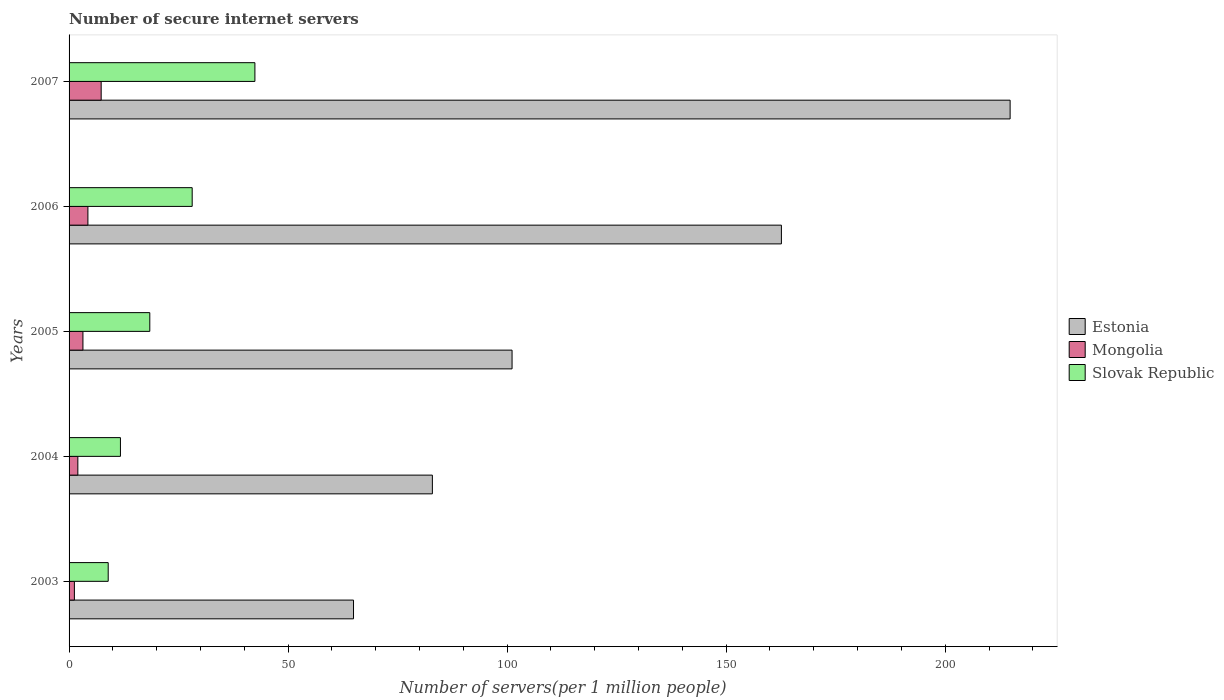How many groups of bars are there?
Keep it short and to the point. 5. How many bars are there on the 5th tick from the bottom?
Your response must be concise. 3. What is the label of the 2nd group of bars from the top?
Ensure brevity in your answer.  2006. In how many cases, is the number of bars for a given year not equal to the number of legend labels?
Your response must be concise. 0. What is the number of secure internet servers in Mongolia in 2003?
Your answer should be very brief. 1.22. Across all years, what is the maximum number of secure internet servers in Mongolia?
Your response must be concise. 7.33. Across all years, what is the minimum number of secure internet servers in Estonia?
Offer a very short reply. 64.93. In which year was the number of secure internet servers in Mongolia maximum?
Your answer should be very brief. 2007. In which year was the number of secure internet servers in Estonia minimum?
Keep it short and to the point. 2003. What is the total number of secure internet servers in Slovak Republic in the graph?
Provide a succinct answer. 109.61. What is the difference between the number of secure internet servers in Estonia in 2004 and that in 2005?
Your response must be concise. -18.19. What is the difference between the number of secure internet servers in Mongolia in 2005 and the number of secure internet servers in Estonia in 2007?
Your response must be concise. -211.65. What is the average number of secure internet servers in Mongolia per year?
Provide a succinct answer. 3.6. In the year 2004, what is the difference between the number of secure internet servers in Slovak Republic and number of secure internet servers in Mongolia?
Provide a succinct answer. 9.72. What is the ratio of the number of secure internet servers in Mongolia in 2004 to that in 2007?
Keep it short and to the point. 0.27. Is the number of secure internet servers in Estonia in 2003 less than that in 2005?
Your answer should be compact. Yes. Is the difference between the number of secure internet servers in Slovak Republic in 2005 and 2007 greater than the difference between the number of secure internet servers in Mongolia in 2005 and 2007?
Provide a short and direct response. No. What is the difference between the highest and the second highest number of secure internet servers in Slovak Republic?
Offer a terse response. 14.32. What is the difference between the highest and the lowest number of secure internet servers in Estonia?
Your answer should be compact. 149.89. What does the 2nd bar from the top in 2007 represents?
Provide a succinct answer. Mongolia. What does the 1st bar from the bottom in 2005 represents?
Offer a terse response. Estonia. Is it the case that in every year, the sum of the number of secure internet servers in Estonia and number of secure internet servers in Slovak Republic is greater than the number of secure internet servers in Mongolia?
Keep it short and to the point. Yes. Are the values on the major ticks of X-axis written in scientific E-notation?
Provide a succinct answer. No. How are the legend labels stacked?
Give a very brief answer. Vertical. What is the title of the graph?
Provide a succinct answer. Number of secure internet servers. Does "Serbia" appear as one of the legend labels in the graph?
Offer a very short reply. No. What is the label or title of the X-axis?
Your answer should be very brief. Number of servers(per 1 million people). What is the label or title of the Y-axis?
Provide a succinct answer. Years. What is the Number of servers(per 1 million people) in Estonia in 2003?
Offer a terse response. 64.93. What is the Number of servers(per 1 million people) of Mongolia in 2003?
Provide a short and direct response. 1.22. What is the Number of servers(per 1 million people) of Slovak Republic in 2003?
Your response must be concise. 8.93. What is the Number of servers(per 1 million people) in Estonia in 2004?
Your answer should be very brief. 82.93. What is the Number of servers(per 1 million people) in Mongolia in 2004?
Your answer should be compact. 2. What is the Number of servers(per 1 million people) of Slovak Republic in 2004?
Make the answer very short. 11.73. What is the Number of servers(per 1 million people) in Estonia in 2005?
Provide a short and direct response. 101.12. What is the Number of servers(per 1 million people) of Mongolia in 2005?
Provide a short and direct response. 3.17. What is the Number of servers(per 1 million people) of Slovak Republic in 2005?
Give a very brief answer. 18.43. What is the Number of servers(per 1 million people) in Estonia in 2006?
Give a very brief answer. 162.61. What is the Number of servers(per 1 million people) in Mongolia in 2006?
Your response must be concise. 4.3. What is the Number of servers(per 1 million people) in Slovak Republic in 2006?
Keep it short and to the point. 28.1. What is the Number of servers(per 1 million people) of Estonia in 2007?
Offer a terse response. 214.82. What is the Number of servers(per 1 million people) in Mongolia in 2007?
Your answer should be very brief. 7.33. What is the Number of servers(per 1 million people) of Slovak Republic in 2007?
Provide a succinct answer. 42.42. Across all years, what is the maximum Number of servers(per 1 million people) in Estonia?
Offer a terse response. 214.82. Across all years, what is the maximum Number of servers(per 1 million people) in Mongolia?
Offer a terse response. 7.33. Across all years, what is the maximum Number of servers(per 1 million people) of Slovak Republic?
Offer a very short reply. 42.42. Across all years, what is the minimum Number of servers(per 1 million people) in Estonia?
Keep it short and to the point. 64.93. Across all years, what is the minimum Number of servers(per 1 million people) of Mongolia?
Make the answer very short. 1.22. Across all years, what is the minimum Number of servers(per 1 million people) of Slovak Republic?
Offer a terse response. 8.93. What is the total Number of servers(per 1 million people) in Estonia in the graph?
Your answer should be very brief. 626.41. What is the total Number of servers(per 1 million people) in Mongolia in the graph?
Your response must be concise. 18.01. What is the total Number of servers(per 1 million people) of Slovak Republic in the graph?
Keep it short and to the point. 109.61. What is the difference between the Number of servers(per 1 million people) in Estonia in 2003 and that in 2004?
Make the answer very short. -18. What is the difference between the Number of servers(per 1 million people) of Mongolia in 2003 and that in 2004?
Offer a very short reply. -0.79. What is the difference between the Number of servers(per 1 million people) in Slovak Republic in 2003 and that in 2004?
Your response must be concise. -2.79. What is the difference between the Number of servers(per 1 million people) in Estonia in 2003 and that in 2005?
Make the answer very short. -36.19. What is the difference between the Number of servers(per 1 million people) in Mongolia in 2003 and that in 2005?
Your answer should be compact. -1.95. What is the difference between the Number of servers(per 1 million people) in Slovak Republic in 2003 and that in 2005?
Provide a short and direct response. -9.49. What is the difference between the Number of servers(per 1 million people) of Estonia in 2003 and that in 2006?
Offer a terse response. -97.68. What is the difference between the Number of servers(per 1 million people) of Mongolia in 2003 and that in 2006?
Give a very brief answer. -3.08. What is the difference between the Number of servers(per 1 million people) of Slovak Republic in 2003 and that in 2006?
Offer a very short reply. -19.17. What is the difference between the Number of servers(per 1 million people) of Estonia in 2003 and that in 2007?
Provide a succinct answer. -149.89. What is the difference between the Number of servers(per 1 million people) in Mongolia in 2003 and that in 2007?
Your response must be concise. -6.11. What is the difference between the Number of servers(per 1 million people) in Slovak Republic in 2003 and that in 2007?
Give a very brief answer. -33.49. What is the difference between the Number of servers(per 1 million people) of Estonia in 2004 and that in 2005?
Give a very brief answer. -18.19. What is the difference between the Number of servers(per 1 million people) of Mongolia in 2004 and that in 2005?
Keep it short and to the point. -1.16. What is the difference between the Number of servers(per 1 million people) of Slovak Republic in 2004 and that in 2005?
Make the answer very short. -6.7. What is the difference between the Number of servers(per 1 million people) of Estonia in 2004 and that in 2006?
Provide a succinct answer. -79.67. What is the difference between the Number of servers(per 1 million people) of Mongolia in 2004 and that in 2006?
Your response must be concise. -2.3. What is the difference between the Number of servers(per 1 million people) of Slovak Republic in 2004 and that in 2006?
Your answer should be very brief. -16.38. What is the difference between the Number of servers(per 1 million people) in Estonia in 2004 and that in 2007?
Provide a succinct answer. -131.88. What is the difference between the Number of servers(per 1 million people) in Mongolia in 2004 and that in 2007?
Your answer should be compact. -5.33. What is the difference between the Number of servers(per 1 million people) of Slovak Republic in 2004 and that in 2007?
Provide a succinct answer. -30.69. What is the difference between the Number of servers(per 1 million people) of Estonia in 2005 and that in 2006?
Provide a short and direct response. -61.48. What is the difference between the Number of servers(per 1 million people) of Mongolia in 2005 and that in 2006?
Your response must be concise. -1.13. What is the difference between the Number of servers(per 1 million people) in Slovak Republic in 2005 and that in 2006?
Give a very brief answer. -9.68. What is the difference between the Number of servers(per 1 million people) in Estonia in 2005 and that in 2007?
Keep it short and to the point. -113.69. What is the difference between the Number of servers(per 1 million people) in Mongolia in 2005 and that in 2007?
Give a very brief answer. -4.16. What is the difference between the Number of servers(per 1 million people) of Slovak Republic in 2005 and that in 2007?
Make the answer very short. -24. What is the difference between the Number of servers(per 1 million people) in Estonia in 2006 and that in 2007?
Provide a succinct answer. -52.21. What is the difference between the Number of servers(per 1 million people) of Mongolia in 2006 and that in 2007?
Give a very brief answer. -3.03. What is the difference between the Number of servers(per 1 million people) in Slovak Republic in 2006 and that in 2007?
Your response must be concise. -14.32. What is the difference between the Number of servers(per 1 million people) of Estonia in 2003 and the Number of servers(per 1 million people) of Mongolia in 2004?
Offer a very short reply. 62.93. What is the difference between the Number of servers(per 1 million people) of Estonia in 2003 and the Number of servers(per 1 million people) of Slovak Republic in 2004?
Your answer should be compact. 53.2. What is the difference between the Number of servers(per 1 million people) of Mongolia in 2003 and the Number of servers(per 1 million people) of Slovak Republic in 2004?
Offer a terse response. -10.51. What is the difference between the Number of servers(per 1 million people) of Estonia in 2003 and the Number of servers(per 1 million people) of Mongolia in 2005?
Keep it short and to the point. 61.76. What is the difference between the Number of servers(per 1 million people) in Estonia in 2003 and the Number of servers(per 1 million people) in Slovak Republic in 2005?
Ensure brevity in your answer.  46.5. What is the difference between the Number of servers(per 1 million people) of Mongolia in 2003 and the Number of servers(per 1 million people) of Slovak Republic in 2005?
Provide a succinct answer. -17.21. What is the difference between the Number of servers(per 1 million people) of Estonia in 2003 and the Number of servers(per 1 million people) of Mongolia in 2006?
Provide a succinct answer. 60.63. What is the difference between the Number of servers(per 1 million people) in Estonia in 2003 and the Number of servers(per 1 million people) in Slovak Republic in 2006?
Make the answer very short. 36.83. What is the difference between the Number of servers(per 1 million people) of Mongolia in 2003 and the Number of servers(per 1 million people) of Slovak Republic in 2006?
Your answer should be compact. -26.89. What is the difference between the Number of servers(per 1 million people) of Estonia in 2003 and the Number of servers(per 1 million people) of Mongolia in 2007?
Your answer should be compact. 57.6. What is the difference between the Number of servers(per 1 million people) of Estonia in 2003 and the Number of servers(per 1 million people) of Slovak Republic in 2007?
Keep it short and to the point. 22.51. What is the difference between the Number of servers(per 1 million people) of Mongolia in 2003 and the Number of servers(per 1 million people) of Slovak Republic in 2007?
Make the answer very short. -41.21. What is the difference between the Number of servers(per 1 million people) in Estonia in 2004 and the Number of servers(per 1 million people) in Mongolia in 2005?
Provide a succinct answer. 79.77. What is the difference between the Number of servers(per 1 million people) of Estonia in 2004 and the Number of servers(per 1 million people) of Slovak Republic in 2005?
Provide a succinct answer. 64.51. What is the difference between the Number of servers(per 1 million people) of Mongolia in 2004 and the Number of servers(per 1 million people) of Slovak Republic in 2005?
Your answer should be compact. -16.42. What is the difference between the Number of servers(per 1 million people) of Estonia in 2004 and the Number of servers(per 1 million people) of Mongolia in 2006?
Your answer should be compact. 78.63. What is the difference between the Number of servers(per 1 million people) in Estonia in 2004 and the Number of servers(per 1 million people) in Slovak Republic in 2006?
Offer a very short reply. 54.83. What is the difference between the Number of servers(per 1 million people) in Mongolia in 2004 and the Number of servers(per 1 million people) in Slovak Republic in 2006?
Your answer should be compact. -26.1. What is the difference between the Number of servers(per 1 million people) of Estonia in 2004 and the Number of servers(per 1 million people) of Mongolia in 2007?
Keep it short and to the point. 75.6. What is the difference between the Number of servers(per 1 million people) of Estonia in 2004 and the Number of servers(per 1 million people) of Slovak Republic in 2007?
Your response must be concise. 40.51. What is the difference between the Number of servers(per 1 million people) in Mongolia in 2004 and the Number of servers(per 1 million people) in Slovak Republic in 2007?
Make the answer very short. -40.42. What is the difference between the Number of servers(per 1 million people) of Estonia in 2005 and the Number of servers(per 1 million people) of Mongolia in 2006?
Your answer should be very brief. 96.82. What is the difference between the Number of servers(per 1 million people) in Estonia in 2005 and the Number of servers(per 1 million people) in Slovak Republic in 2006?
Keep it short and to the point. 73.02. What is the difference between the Number of servers(per 1 million people) of Mongolia in 2005 and the Number of servers(per 1 million people) of Slovak Republic in 2006?
Your response must be concise. -24.94. What is the difference between the Number of servers(per 1 million people) of Estonia in 2005 and the Number of servers(per 1 million people) of Mongolia in 2007?
Give a very brief answer. 93.8. What is the difference between the Number of servers(per 1 million people) of Estonia in 2005 and the Number of servers(per 1 million people) of Slovak Republic in 2007?
Your answer should be very brief. 58.7. What is the difference between the Number of servers(per 1 million people) of Mongolia in 2005 and the Number of servers(per 1 million people) of Slovak Republic in 2007?
Provide a short and direct response. -39.26. What is the difference between the Number of servers(per 1 million people) of Estonia in 2006 and the Number of servers(per 1 million people) of Mongolia in 2007?
Ensure brevity in your answer.  155.28. What is the difference between the Number of servers(per 1 million people) in Estonia in 2006 and the Number of servers(per 1 million people) in Slovak Republic in 2007?
Give a very brief answer. 120.18. What is the difference between the Number of servers(per 1 million people) in Mongolia in 2006 and the Number of servers(per 1 million people) in Slovak Republic in 2007?
Ensure brevity in your answer.  -38.12. What is the average Number of servers(per 1 million people) in Estonia per year?
Provide a short and direct response. 125.28. What is the average Number of servers(per 1 million people) in Mongolia per year?
Provide a short and direct response. 3.6. What is the average Number of servers(per 1 million people) of Slovak Republic per year?
Keep it short and to the point. 21.92. In the year 2003, what is the difference between the Number of servers(per 1 million people) of Estonia and Number of servers(per 1 million people) of Mongolia?
Provide a short and direct response. 63.71. In the year 2003, what is the difference between the Number of servers(per 1 million people) of Estonia and Number of servers(per 1 million people) of Slovak Republic?
Offer a very short reply. 56. In the year 2003, what is the difference between the Number of servers(per 1 million people) in Mongolia and Number of servers(per 1 million people) in Slovak Republic?
Your answer should be compact. -7.72. In the year 2004, what is the difference between the Number of servers(per 1 million people) of Estonia and Number of servers(per 1 million people) of Mongolia?
Offer a terse response. 80.93. In the year 2004, what is the difference between the Number of servers(per 1 million people) of Estonia and Number of servers(per 1 million people) of Slovak Republic?
Offer a terse response. 71.21. In the year 2004, what is the difference between the Number of servers(per 1 million people) of Mongolia and Number of servers(per 1 million people) of Slovak Republic?
Your answer should be compact. -9.72. In the year 2005, what is the difference between the Number of servers(per 1 million people) in Estonia and Number of servers(per 1 million people) in Mongolia?
Offer a very short reply. 97.96. In the year 2005, what is the difference between the Number of servers(per 1 million people) of Estonia and Number of servers(per 1 million people) of Slovak Republic?
Your response must be concise. 82.7. In the year 2005, what is the difference between the Number of servers(per 1 million people) in Mongolia and Number of servers(per 1 million people) in Slovak Republic?
Your response must be concise. -15.26. In the year 2006, what is the difference between the Number of servers(per 1 million people) of Estonia and Number of servers(per 1 million people) of Mongolia?
Your answer should be very brief. 158.31. In the year 2006, what is the difference between the Number of servers(per 1 million people) of Estonia and Number of servers(per 1 million people) of Slovak Republic?
Your response must be concise. 134.5. In the year 2006, what is the difference between the Number of servers(per 1 million people) in Mongolia and Number of servers(per 1 million people) in Slovak Republic?
Your answer should be very brief. -23.8. In the year 2007, what is the difference between the Number of servers(per 1 million people) in Estonia and Number of servers(per 1 million people) in Mongolia?
Keep it short and to the point. 207.49. In the year 2007, what is the difference between the Number of servers(per 1 million people) in Estonia and Number of servers(per 1 million people) in Slovak Republic?
Your response must be concise. 172.39. In the year 2007, what is the difference between the Number of servers(per 1 million people) in Mongolia and Number of servers(per 1 million people) in Slovak Republic?
Your answer should be very brief. -35.09. What is the ratio of the Number of servers(per 1 million people) of Estonia in 2003 to that in 2004?
Provide a short and direct response. 0.78. What is the ratio of the Number of servers(per 1 million people) in Mongolia in 2003 to that in 2004?
Your response must be concise. 0.61. What is the ratio of the Number of servers(per 1 million people) of Slovak Republic in 2003 to that in 2004?
Give a very brief answer. 0.76. What is the ratio of the Number of servers(per 1 million people) in Estonia in 2003 to that in 2005?
Provide a succinct answer. 0.64. What is the ratio of the Number of servers(per 1 million people) of Mongolia in 2003 to that in 2005?
Your answer should be very brief. 0.38. What is the ratio of the Number of servers(per 1 million people) in Slovak Republic in 2003 to that in 2005?
Offer a terse response. 0.48. What is the ratio of the Number of servers(per 1 million people) in Estonia in 2003 to that in 2006?
Give a very brief answer. 0.4. What is the ratio of the Number of servers(per 1 million people) in Mongolia in 2003 to that in 2006?
Provide a succinct answer. 0.28. What is the ratio of the Number of servers(per 1 million people) in Slovak Republic in 2003 to that in 2006?
Offer a very short reply. 0.32. What is the ratio of the Number of servers(per 1 million people) in Estonia in 2003 to that in 2007?
Keep it short and to the point. 0.3. What is the ratio of the Number of servers(per 1 million people) in Mongolia in 2003 to that in 2007?
Provide a short and direct response. 0.17. What is the ratio of the Number of servers(per 1 million people) of Slovak Republic in 2003 to that in 2007?
Offer a terse response. 0.21. What is the ratio of the Number of servers(per 1 million people) in Estonia in 2004 to that in 2005?
Give a very brief answer. 0.82. What is the ratio of the Number of servers(per 1 million people) of Mongolia in 2004 to that in 2005?
Provide a short and direct response. 0.63. What is the ratio of the Number of servers(per 1 million people) in Slovak Republic in 2004 to that in 2005?
Provide a succinct answer. 0.64. What is the ratio of the Number of servers(per 1 million people) in Estonia in 2004 to that in 2006?
Offer a terse response. 0.51. What is the ratio of the Number of servers(per 1 million people) in Mongolia in 2004 to that in 2006?
Give a very brief answer. 0.47. What is the ratio of the Number of servers(per 1 million people) in Slovak Republic in 2004 to that in 2006?
Offer a terse response. 0.42. What is the ratio of the Number of servers(per 1 million people) in Estonia in 2004 to that in 2007?
Provide a short and direct response. 0.39. What is the ratio of the Number of servers(per 1 million people) of Mongolia in 2004 to that in 2007?
Your answer should be very brief. 0.27. What is the ratio of the Number of servers(per 1 million people) in Slovak Republic in 2004 to that in 2007?
Offer a very short reply. 0.28. What is the ratio of the Number of servers(per 1 million people) in Estonia in 2005 to that in 2006?
Provide a succinct answer. 0.62. What is the ratio of the Number of servers(per 1 million people) in Mongolia in 2005 to that in 2006?
Make the answer very short. 0.74. What is the ratio of the Number of servers(per 1 million people) in Slovak Republic in 2005 to that in 2006?
Your answer should be compact. 0.66. What is the ratio of the Number of servers(per 1 million people) in Estonia in 2005 to that in 2007?
Ensure brevity in your answer.  0.47. What is the ratio of the Number of servers(per 1 million people) in Mongolia in 2005 to that in 2007?
Offer a very short reply. 0.43. What is the ratio of the Number of servers(per 1 million people) of Slovak Republic in 2005 to that in 2007?
Ensure brevity in your answer.  0.43. What is the ratio of the Number of servers(per 1 million people) in Estonia in 2006 to that in 2007?
Make the answer very short. 0.76. What is the ratio of the Number of servers(per 1 million people) in Mongolia in 2006 to that in 2007?
Give a very brief answer. 0.59. What is the ratio of the Number of servers(per 1 million people) in Slovak Republic in 2006 to that in 2007?
Offer a very short reply. 0.66. What is the difference between the highest and the second highest Number of servers(per 1 million people) of Estonia?
Your answer should be compact. 52.21. What is the difference between the highest and the second highest Number of servers(per 1 million people) of Mongolia?
Your response must be concise. 3.03. What is the difference between the highest and the second highest Number of servers(per 1 million people) in Slovak Republic?
Provide a short and direct response. 14.32. What is the difference between the highest and the lowest Number of servers(per 1 million people) of Estonia?
Provide a succinct answer. 149.89. What is the difference between the highest and the lowest Number of servers(per 1 million people) in Mongolia?
Your answer should be very brief. 6.11. What is the difference between the highest and the lowest Number of servers(per 1 million people) of Slovak Republic?
Your answer should be very brief. 33.49. 